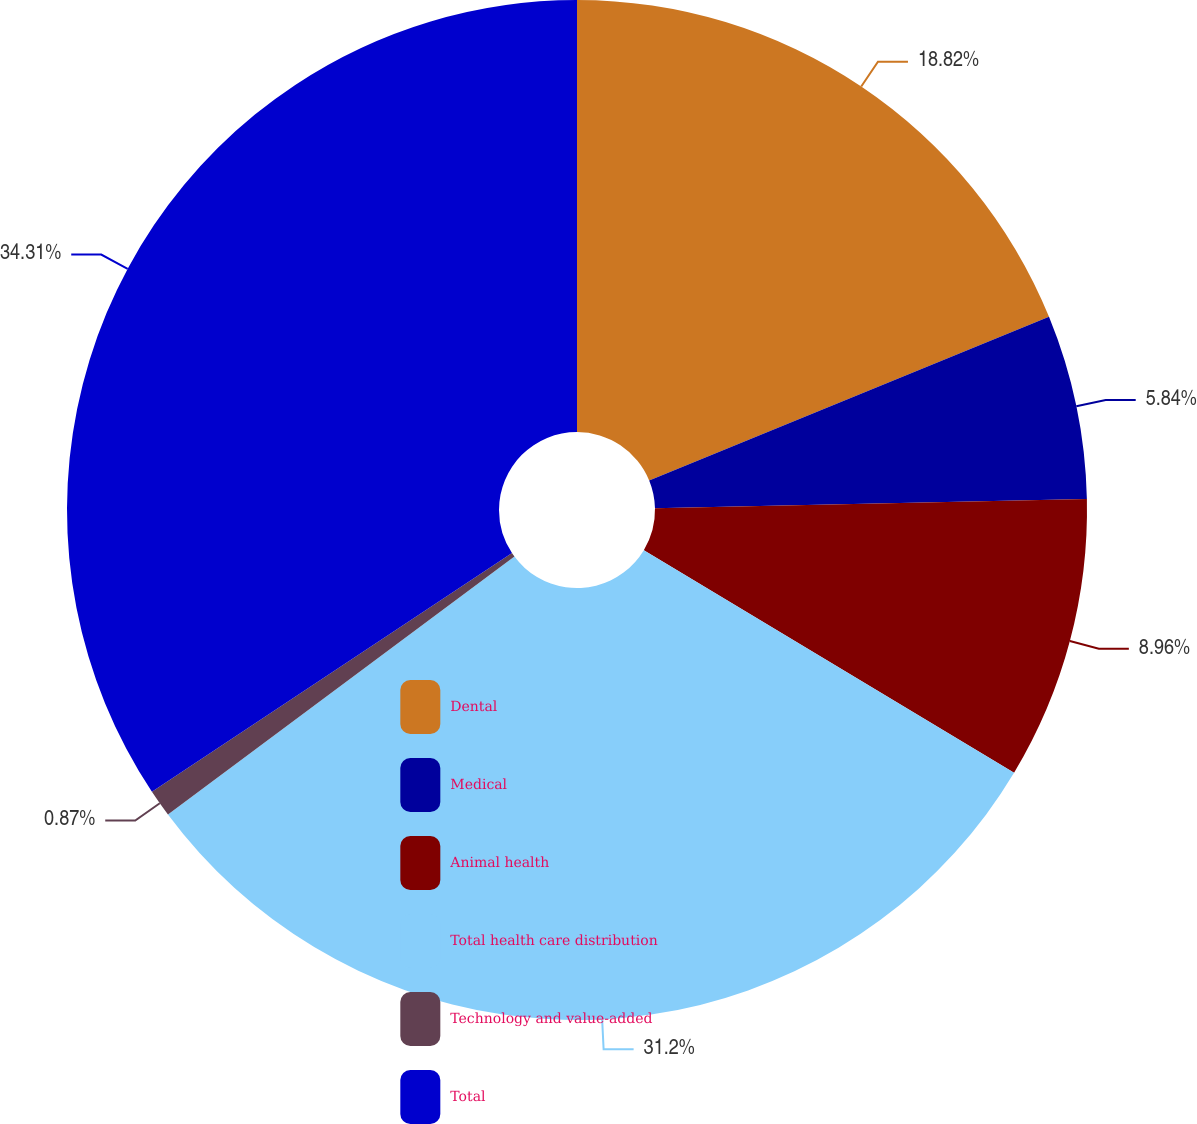Convert chart to OTSL. <chart><loc_0><loc_0><loc_500><loc_500><pie_chart><fcel>Dental<fcel>Medical<fcel>Animal health<fcel>Total health care distribution<fcel>Technology and value-added<fcel>Total<nl><fcel>18.82%<fcel>5.84%<fcel>8.96%<fcel>31.2%<fcel>0.87%<fcel>34.32%<nl></chart> 